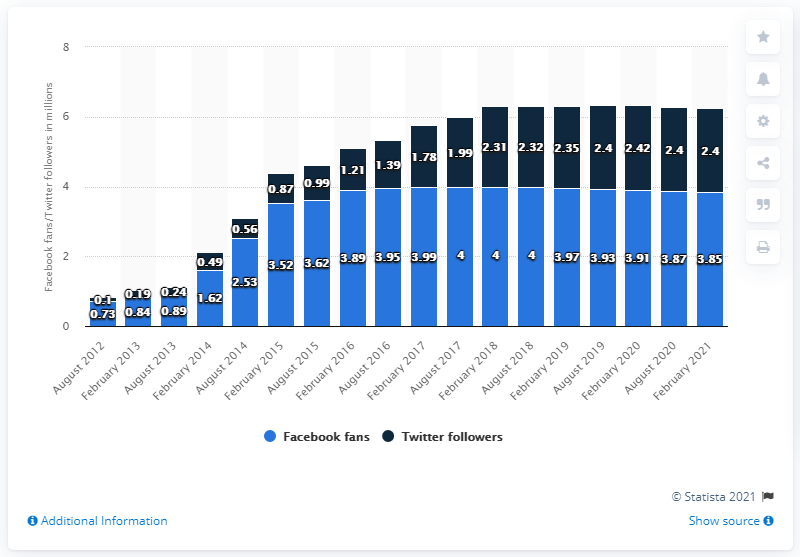Indicate a few pertinent items in this graphic. As of February 2021, the Seattle Seahawks football team had 3.85 million Facebook followers. The difference between the shortest light blue bar and the tallest dark blue bar is 1.69. The common value of Facebook fans between August 2017 and 2018 was approximately 4. 